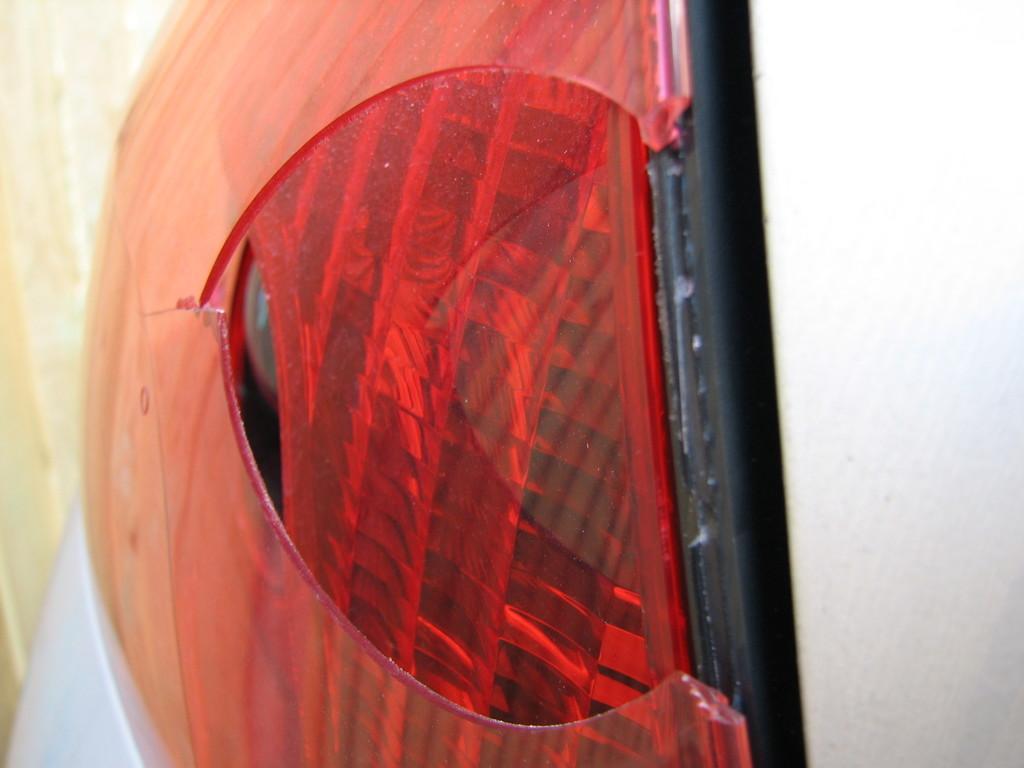Describe this image in one or two sentences. In this image we can see the vehicle headlight. 